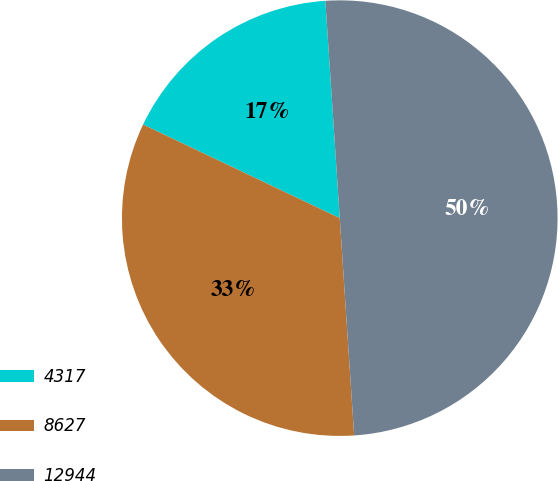Convert chart. <chart><loc_0><loc_0><loc_500><loc_500><pie_chart><fcel>4317<fcel>8627<fcel>12944<nl><fcel>16.88%<fcel>33.12%<fcel>50.0%<nl></chart> 